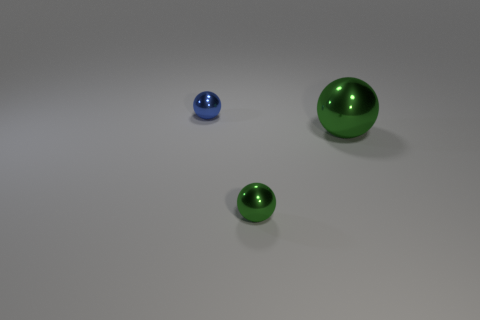Subtract all small metallic balls. How many balls are left? 1 Subtract all cyan cylinders. How many green spheres are left? 2 Subtract 1 spheres. How many spheres are left? 2 Add 2 small purple matte blocks. How many objects exist? 5 Add 1 small blue metal balls. How many small blue metal balls are left? 2 Add 2 tiny blue matte cylinders. How many tiny blue matte cylinders exist? 2 Subtract 0 purple balls. How many objects are left? 3 Subtract all tiny gray objects. Subtract all green metallic balls. How many objects are left? 1 